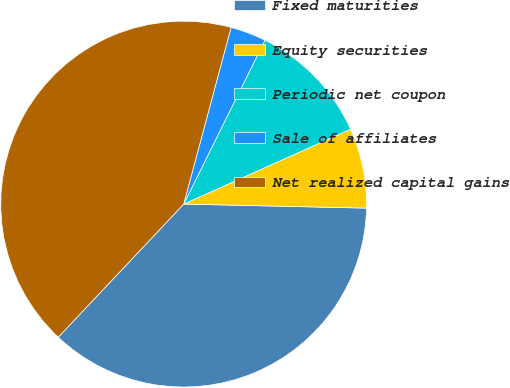<chart> <loc_0><loc_0><loc_500><loc_500><pie_chart><fcel>Fixed maturities<fcel>Equity securities<fcel>Periodic net coupon<fcel>Sale of affiliates<fcel>Net realized capital gains<nl><fcel>36.67%<fcel>7.06%<fcel>10.96%<fcel>3.16%<fcel>42.14%<nl></chart> 